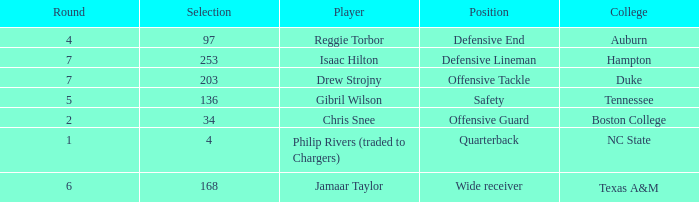Which Position has a Player of gibril wilson? Safety. 